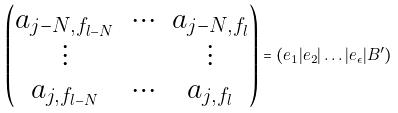<formula> <loc_0><loc_0><loc_500><loc_500>\begin{pmatrix} a _ { j - N , f _ { l - N } } & \hdots & a _ { j - N , f _ { l } } \\ \vdots & & \vdots \\ a _ { j , f _ { l - N } } & \hdots & a _ { j , f _ { l } } \end{pmatrix} = ( e _ { 1 } | e _ { 2 } | \dots | e _ { \epsilon } | B ^ { \prime } )</formula> 